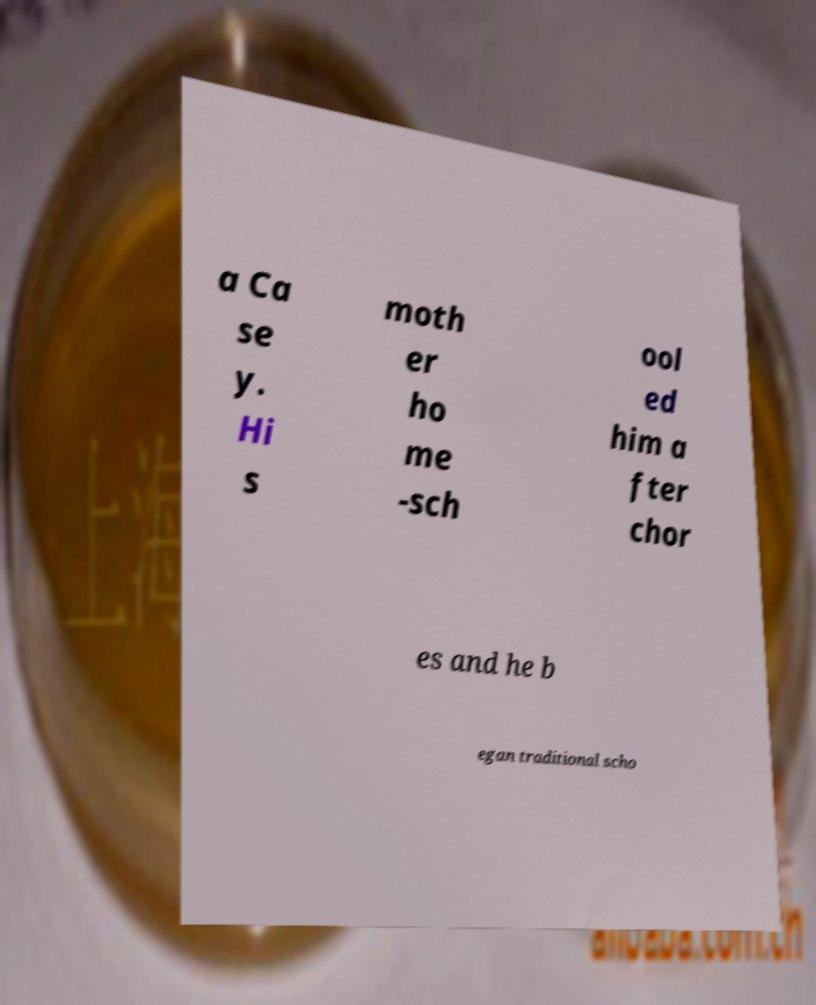Can you read and provide the text displayed in the image?This photo seems to have some interesting text. Can you extract and type it out for me? a Ca se y. Hi s moth er ho me -sch ool ed him a fter chor es and he b egan traditional scho 